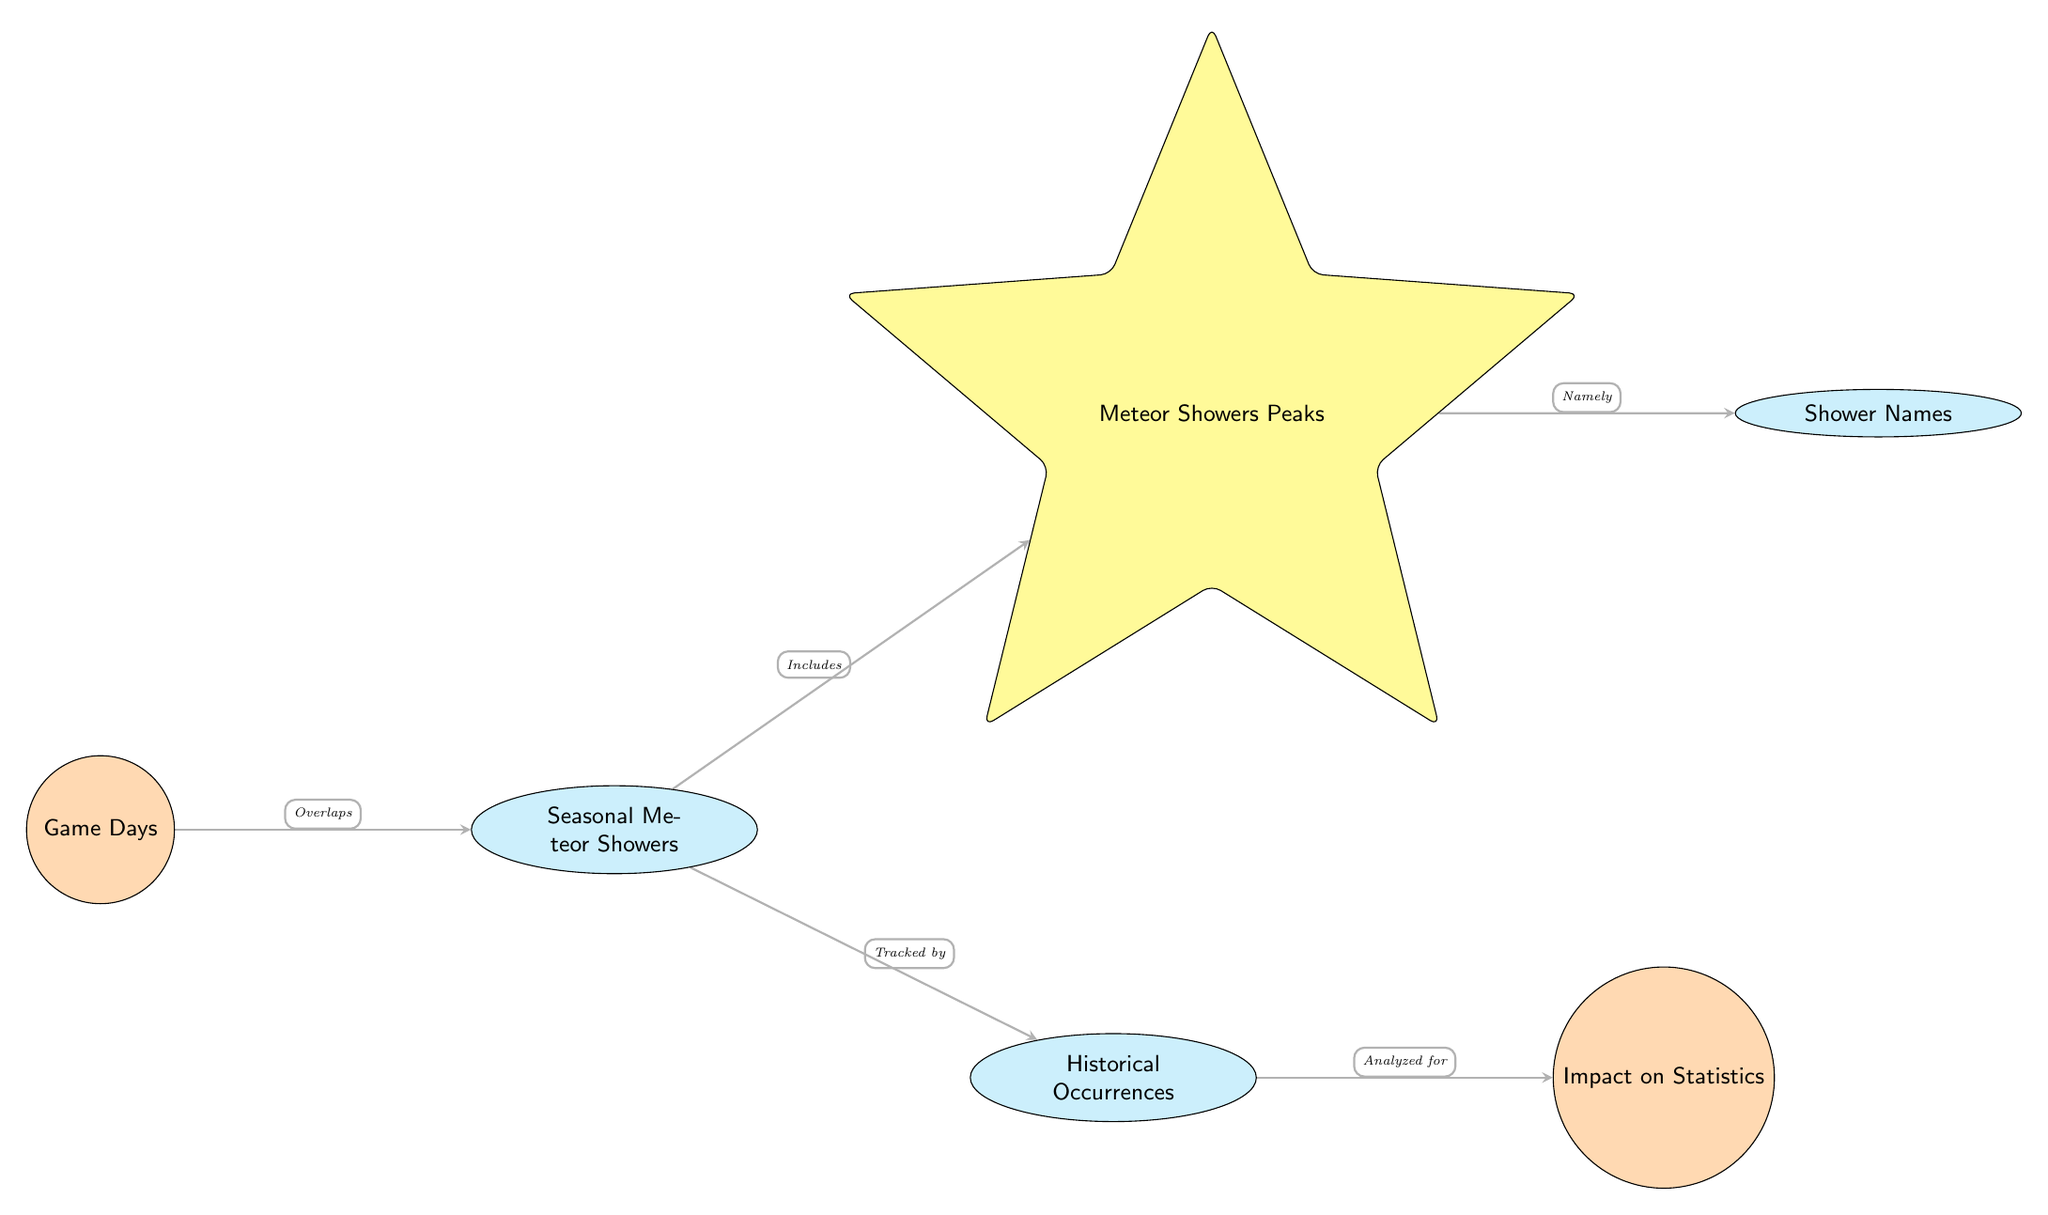What two main categories are connected by an arrow in the diagram? The diagram has an arrow connecting "Game Days" and "Seasonal Meteor Showers," indicating a relationship between these two categories.
Answer: Game Days and Seasonal Meteor Showers What type of nodes does "Meteor Showers Peaks" represent? "Meteor Showers Peaks" is indicated as a comet shape in the diagram, which denotes its specific categorization as a peak event within the seasonal meteor showers.
Answer: Comet How many nodes are explicitly mentioned in the diagram? The diagram includes a total of five nodes: Game Days, Seasonal Meteor Showers, Meteor Showers Peaks, Shower Names, and Historical Occurrences.
Answer: Five What is analyzed for its impact on statistics according to the diagram? The diagram indicates that "Historical Occurrences" is analyzed for its impact on "Impact on Statistics," showing a clear relationship where one influences the other.
Answer: Historical Occurrences Which node tracks the "Seasonal Meteor Showers"? The diagram states that "Seasonal Meteor Showers" is tracked by "Historical Occurrences," indicating that historical data is used to monitor meteor showers.
Answer: Historical Occurrences What kind of relationship does "Meteor Showers Peaks" have with "Shower Names"? The relationship between "Meteor Showers Peaks" and "Shower Names" is described as a direct connection with the phrase "Namely," indicating that the peaks are specifically identified by their names.
Answer: Namely How are "Game Days" and "Seasonal Meteor Showers" related according to the diagram? The arrow represents that "Game Days" overlaps with "Seasonal Meteor Showers," suggesting that these two occurrences can happen simultaneously.
Answer: Overlaps What type of connections are used to depict the relationships in the diagram? The relationships in the diagram are depicted using directed arrows, indicating the flow of influence or relationship from one node to another.
Answer: Directed arrows Which node represents the effect analyzed in the diagram? The node "Impact on Statistics" represents the analyzed effect in the diagram, showing that the previous nodes contribute to this analysis outcome.
Answer: Impact on Statistics 